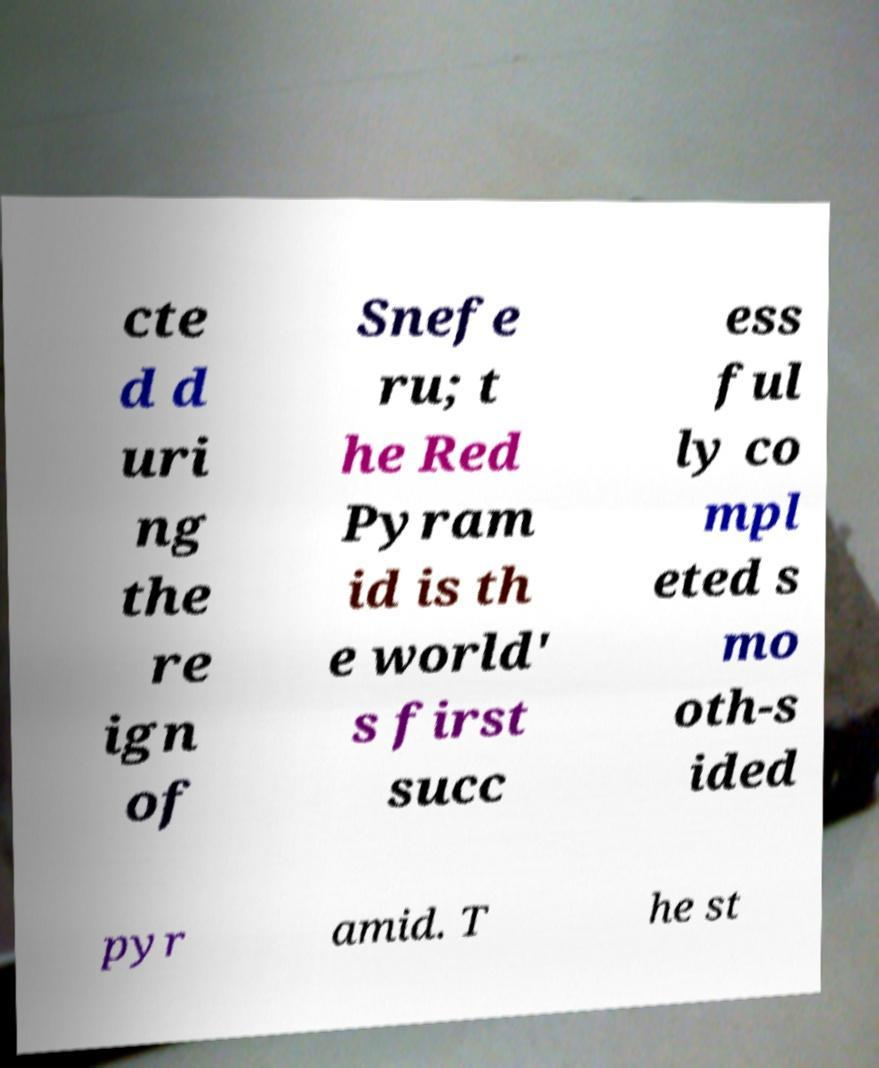Could you assist in decoding the text presented in this image and type it out clearly? cte d d uri ng the re ign of Snefe ru; t he Red Pyram id is th e world' s first succ ess ful ly co mpl eted s mo oth-s ided pyr amid. T he st 